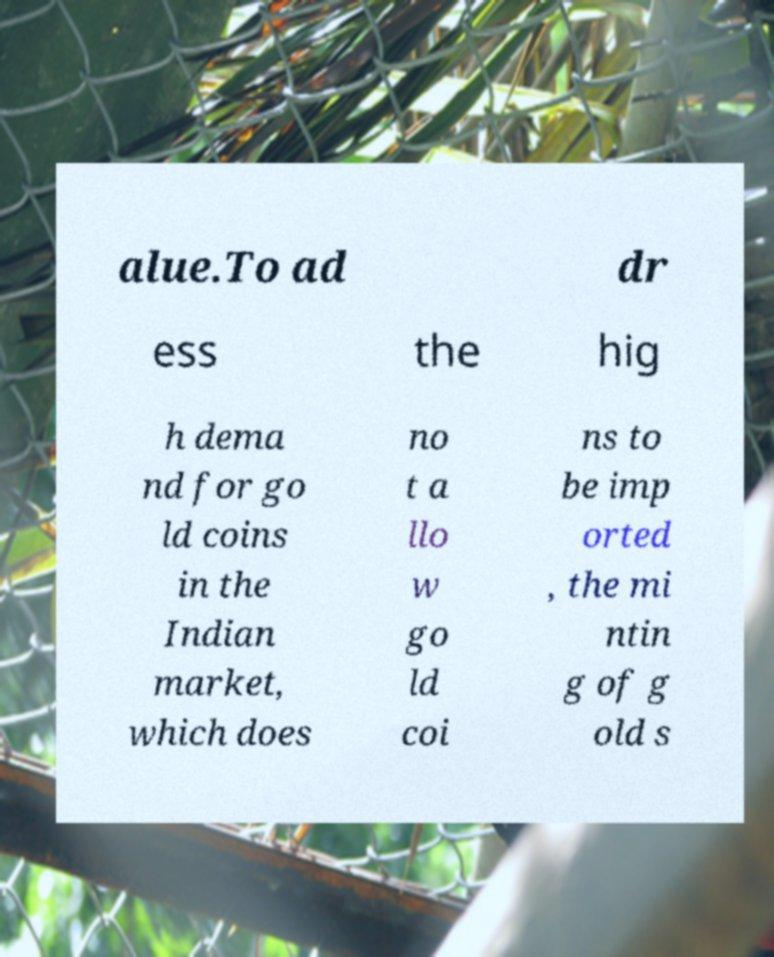Could you assist in decoding the text presented in this image and type it out clearly? alue.To ad dr ess the hig h dema nd for go ld coins in the Indian market, which does no t a llo w go ld coi ns to be imp orted , the mi ntin g of g old s 